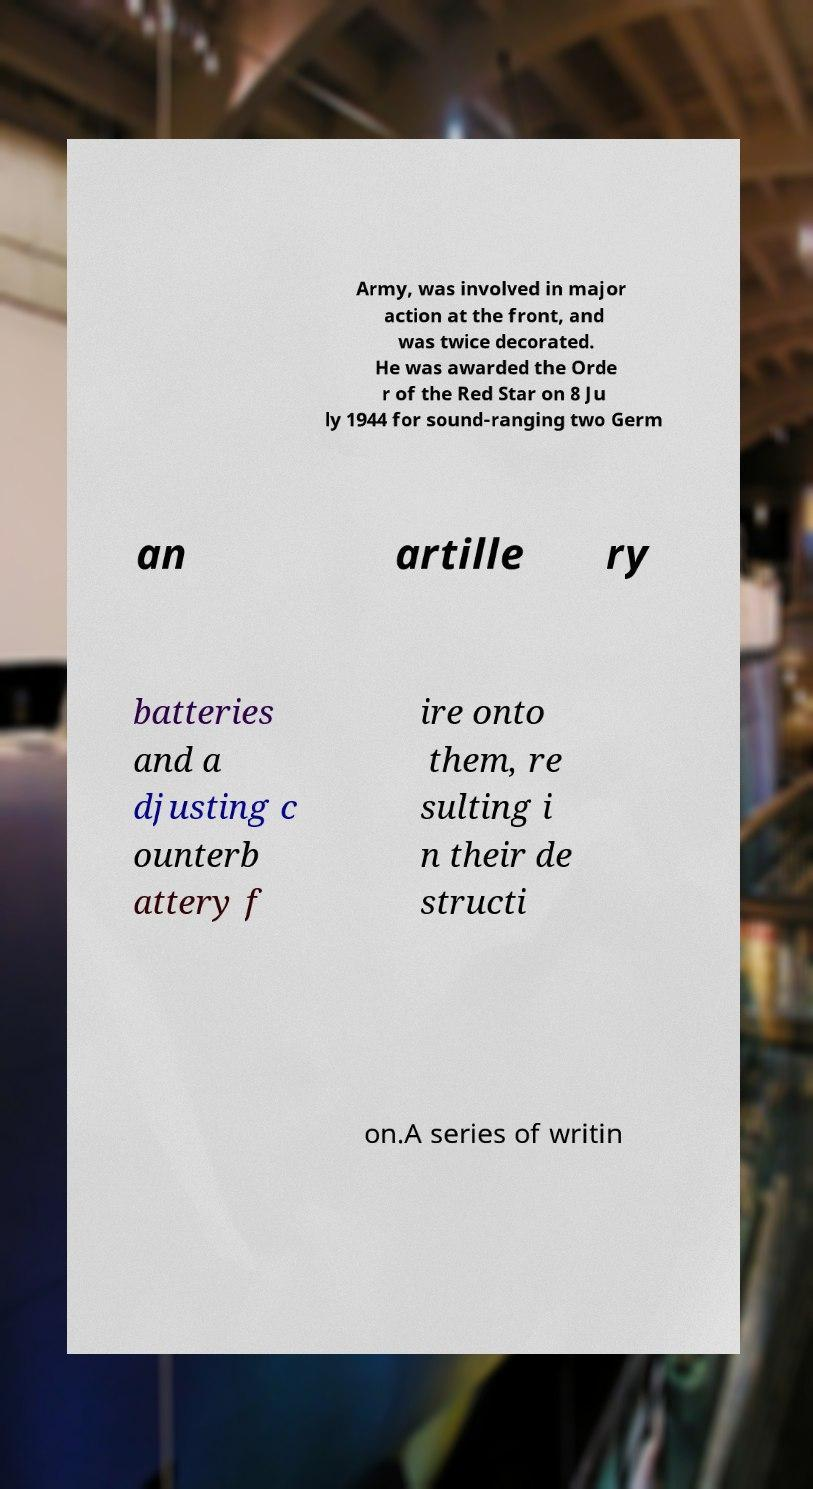Could you assist in decoding the text presented in this image and type it out clearly? Army, was involved in major action at the front, and was twice decorated. He was awarded the Orde r of the Red Star on 8 Ju ly 1944 for sound-ranging two Germ an artille ry batteries and a djusting c ounterb attery f ire onto them, re sulting i n their de structi on.A series of writin 